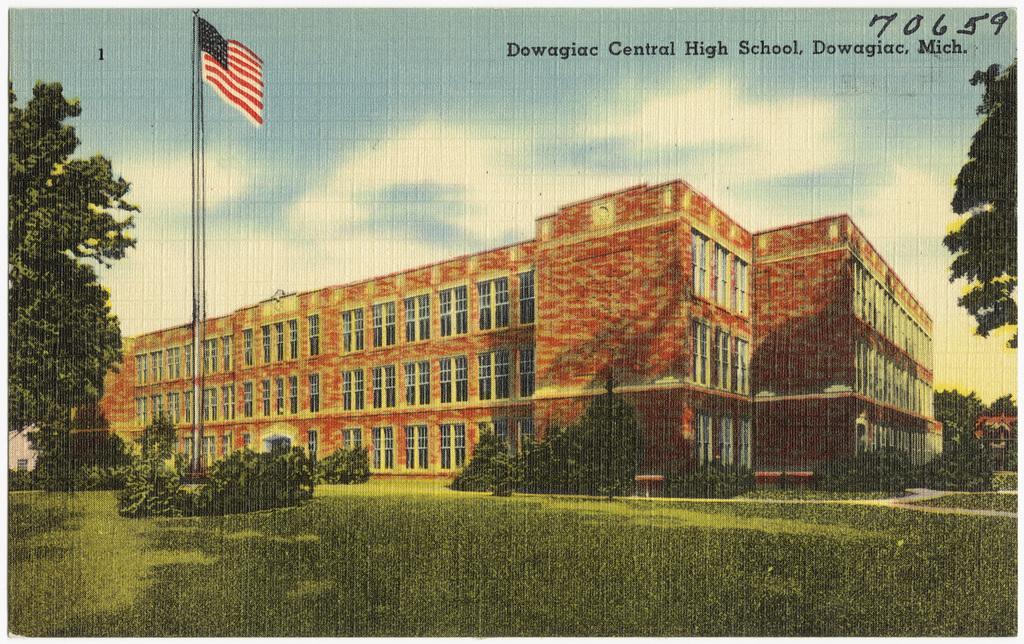Could you give a brief overview of what you see in this image? This image is a poster. In the center of the image there is a building. There is a flag. There are trees. At the bottom of the image there is grass. 